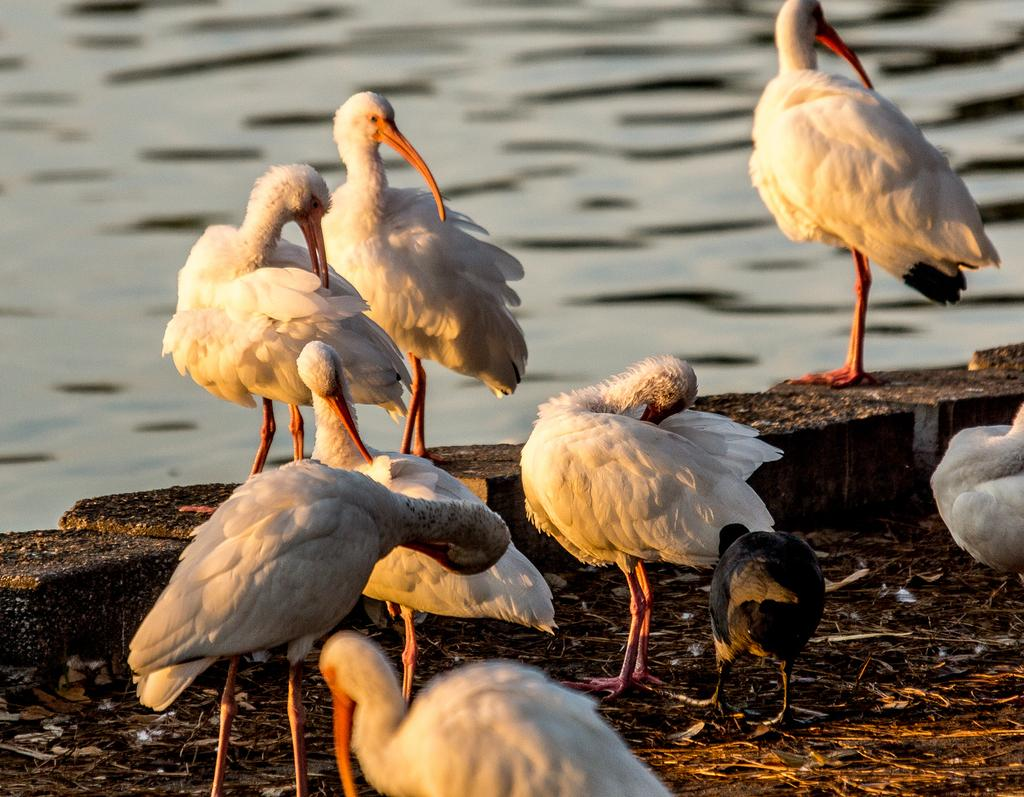What type of animals can be seen in the image? There are white birds and a black bird in the image. What are the positions of the birds in the image? The white birds and the black bird are standing. What is visible in the background of the image? There is water visible in the image. What type of birthday celebration is happening in the image? There is no indication of a birthday celebration in the image. Can you hear the birds singing in the image? The image is a visual representation, so we cannot hear the birds singing. 